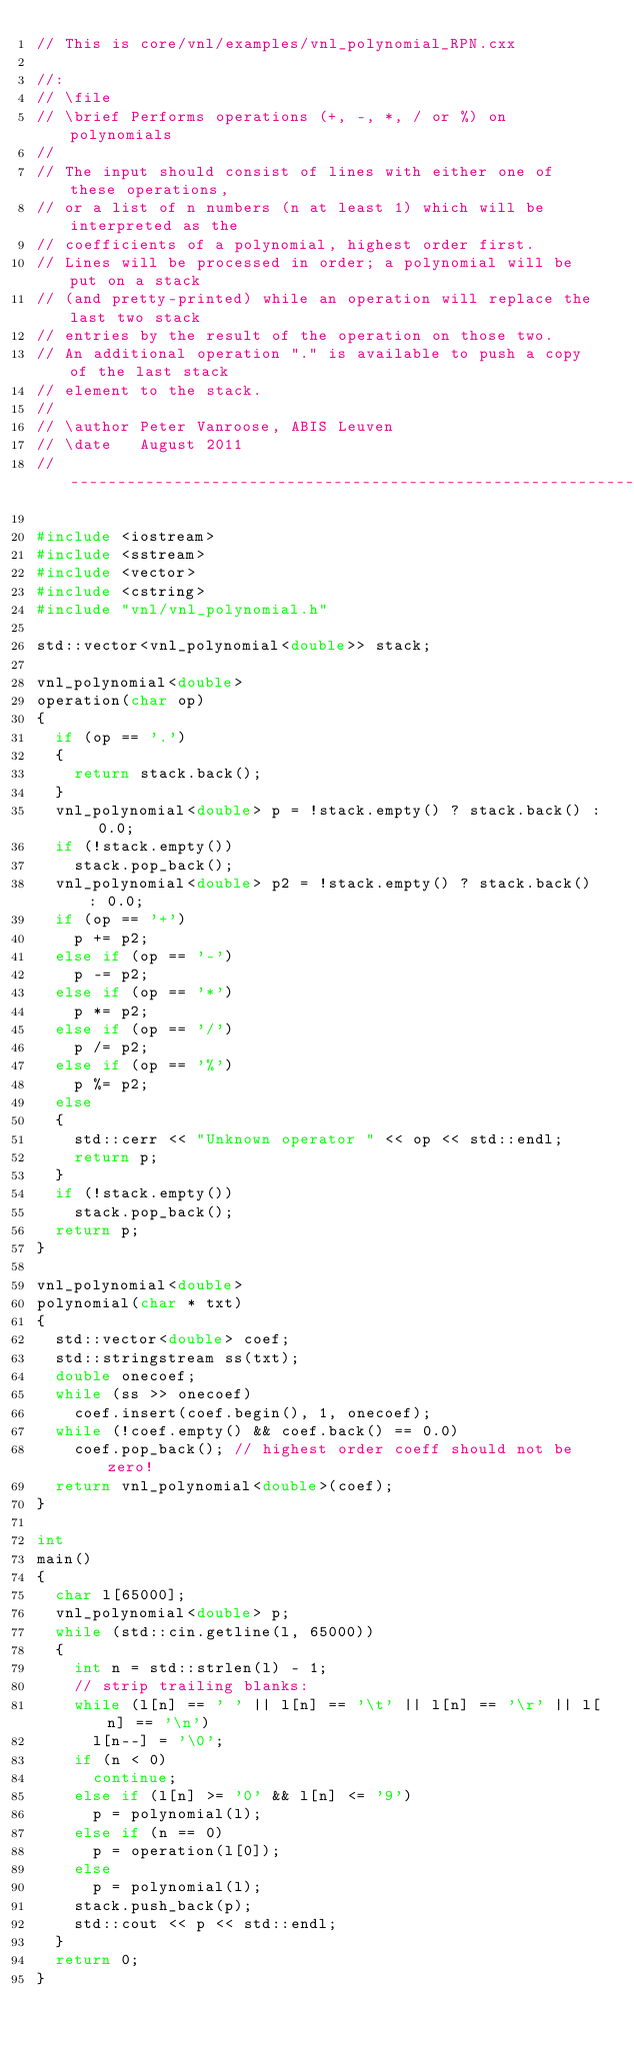<code> <loc_0><loc_0><loc_500><loc_500><_C++_>// This is core/vnl/examples/vnl_polynomial_RPN.cxx

//:
// \file
// \brief Performs operations (+, -, *, / or %) on polynomials
//
// The input should consist of lines with either one of these operations,
// or a list of n numbers (n at least 1) which will be interpreted as the
// coefficients of a polynomial, highest order first.
// Lines will be processed in order; a polynomial will be put on a stack
// (and pretty-printed) while an operation will replace the last two stack
// entries by the result of the operation on those two.
// An additional operation "." is available to push a copy of the last stack
// element to the stack.
//
// \author Peter Vanroose, ABIS Leuven
// \date   August 2011
//-----------------------------------------------------------------------------

#include <iostream>
#include <sstream>
#include <vector>
#include <cstring>
#include "vnl/vnl_polynomial.h"

std::vector<vnl_polynomial<double>> stack;

vnl_polynomial<double>
operation(char op)
{
  if (op == '.')
  {
    return stack.back();
  }
  vnl_polynomial<double> p = !stack.empty() ? stack.back() : 0.0;
  if (!stack.empty())
    stack.pop_back();
  vnl_polynomial<double> p2 = !stack.empty() ? stack.back() : 0.0;
  if (op == '+')
    p += p2;
  else if (op == '-')
    p -= p2;
  else if (op == '*')
    p *= p2;
  else if (op == '/')
    p /= p2;
  else if (op == '%')
    p %= p2;
  else
  {
    std::cerr << "Unknown operator " << op << std::endl;
    return p;
  }
  if (!stack.empty())
    stack.pop_back();
  return p;
}

vnl_polynomial<double>
polynomial(char * txt)
{
  std::vector<double> coef;
  std::stringstream ss(txt);
  double onecoef;
  while (ss >> onecoef)
    coef.insert(coef.begin(), 1, onecoef);
  while (!coef.empty() && coef.back() == 0.0)
    coef.pop_back(); // highest order coeff should not be zero!
  return vnl_polynomial<double>(coef);
}

int
main()
{
  char l[65000];
  vnl_polynomial<double> p;
  while (std::cin.getline(l, 65000))
  {
    int n = std::strlen(l) - 1;
    // strip trailing blanks:
    while (l[n] == ' ' || l[n] == '\t' || l[n] == '\r' || l[n] == '\n')
      l[n--] = '\0';
    if (n < 0)
      continue;
    else if (l[n] >= '0' && l[n] <= '9')
      p = polynomial(l);
    else if (n == 0)
      p = operation(l[0]);
    else
      p = polynomial(l);
    stack.push_back(p);
    std::cout << p << std::endl;
  }
  return 0;
}
</code> 